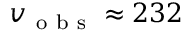Convert formula to latex. <formula><loc_0><loc_0><loc_500><loc_500>v _ { o b s } \approx 2 3 2</formula> 